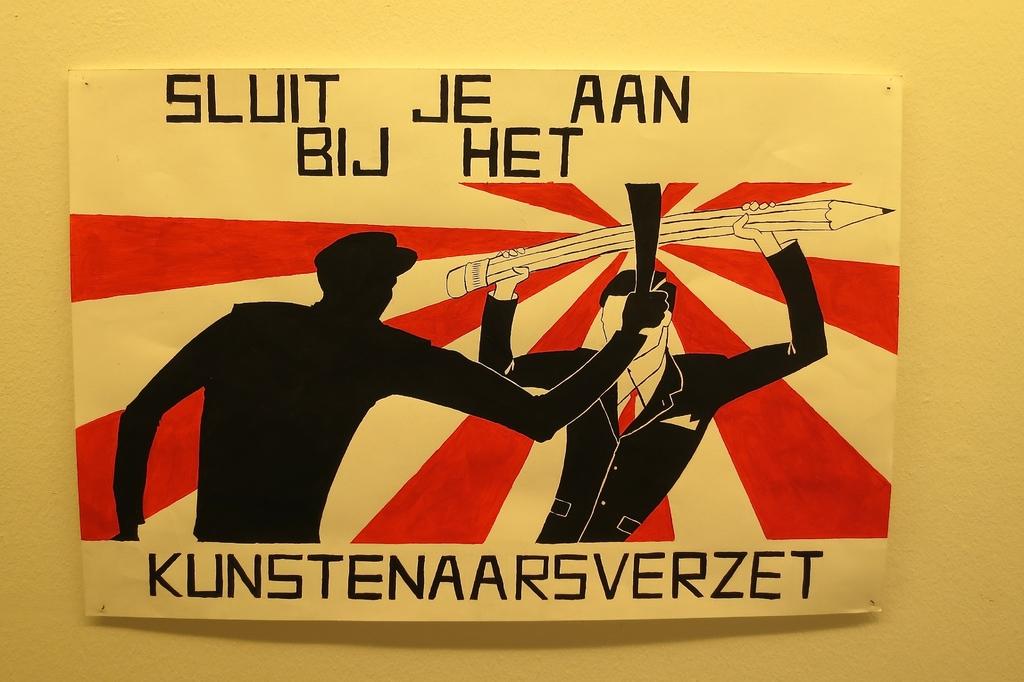What is this poster trying to say?
Your answer should be compact. Unanswerable. 